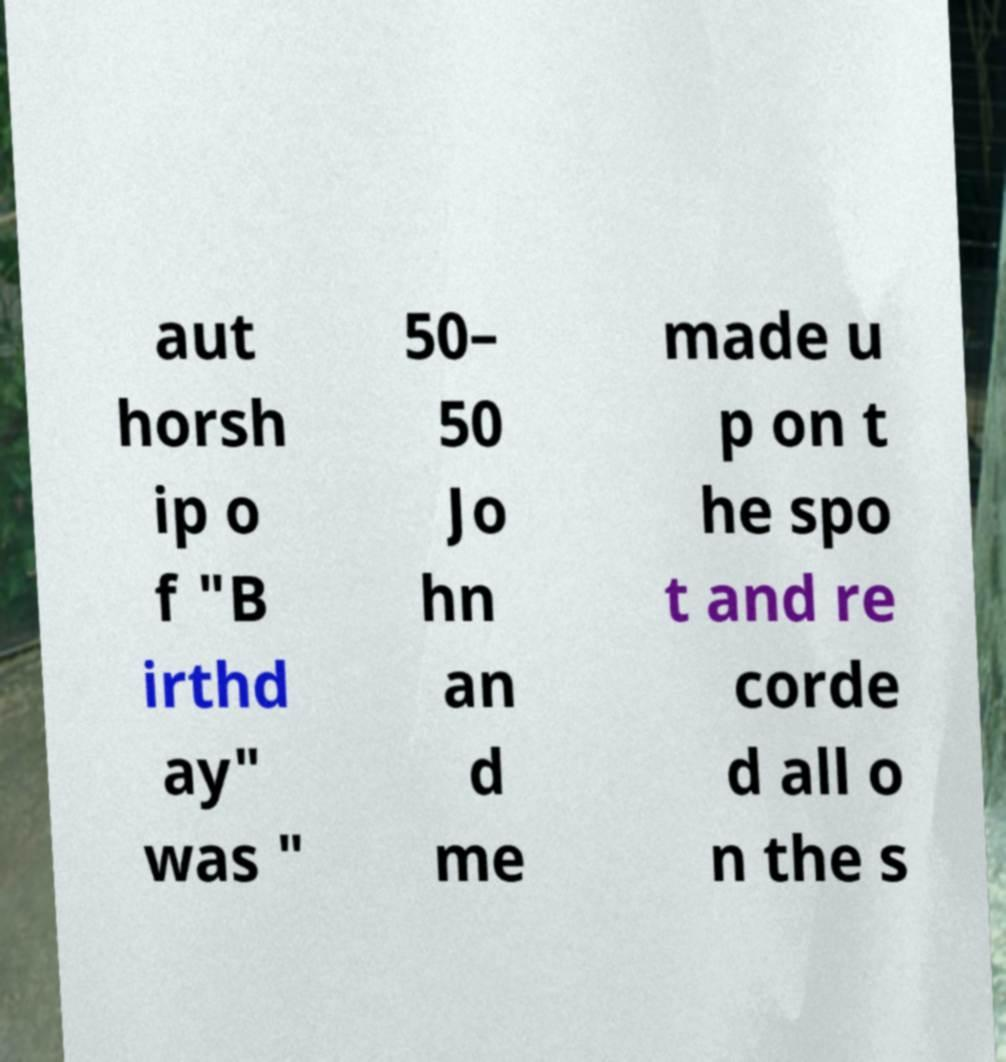I need the written content from this picture converted into text. Can you do that? aut horsh ip o f "B irthd ay" was " 50– 50 Jo hn an d me made u p on t he spo t and re corde d all o n the s 